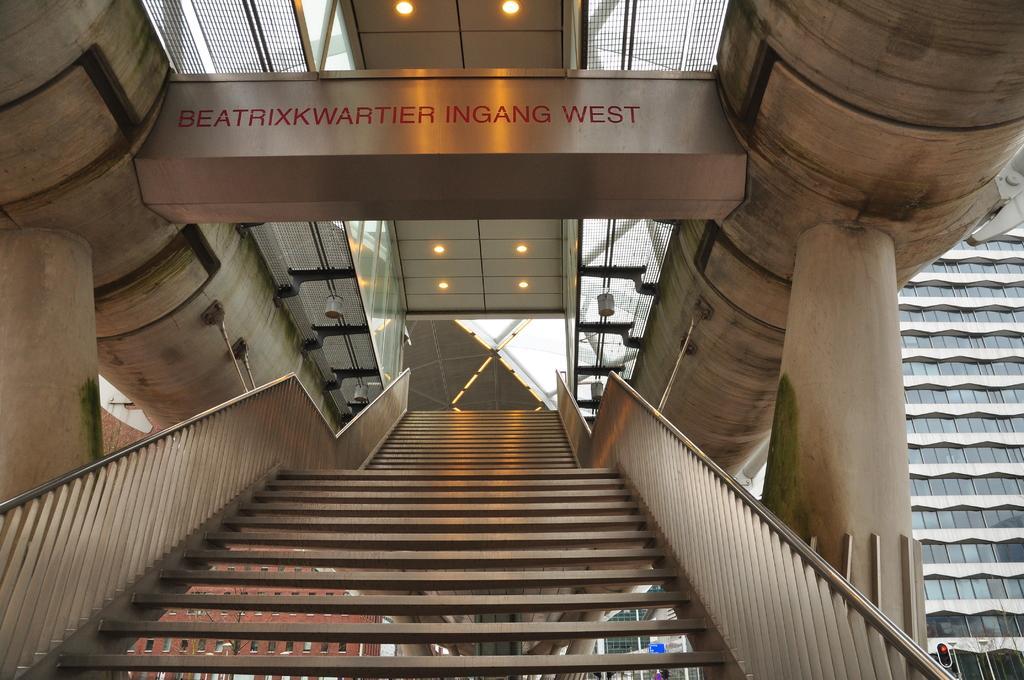In one or two sentences, can you explain what this image depicts? In this picture we can see an inside view of a building, where we can see pillars, lights and some objects. 